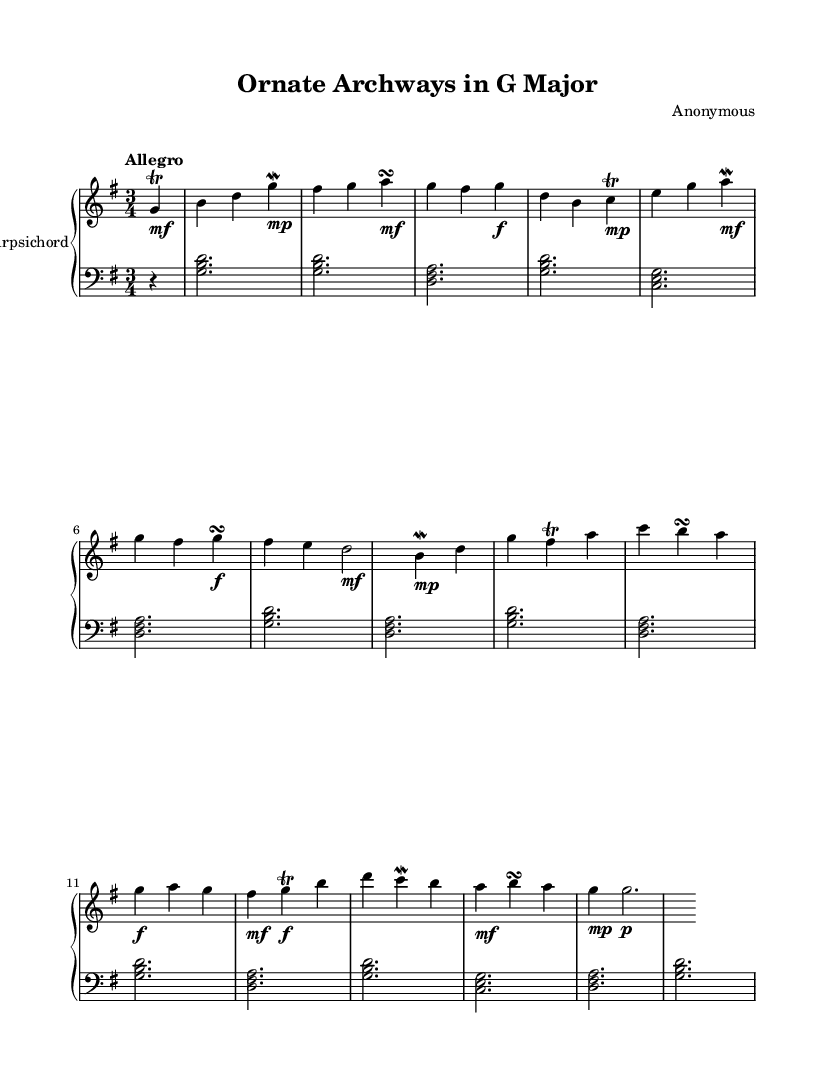What is the key signature of this music? The key signature is indicated at the beginning of the score, showing one sharp which is F#. This means the music is in G major.
Answer: G major What is the time signature of this piece? The time signature appears at the beginning as well, indicating three beats per measure, written as 3/4.
Answer: 3/4 What is the tempo marking of the composition? The tempo marking is located at the beginning of the score and states "Allegro," which indicates a fast tempo.
Answer: Allegro How many measures does the upper staff contain? By counting the number of vertical lines separating the notes in the upper staff, we see there are 14 measures.
Answer: 14 What type of ornamentation is used most frequently in this piece? Upon reviewing the upper staff, we see markings for trills and mordents applied to several notes, indicating the use of these ornaments.
Answer: Trills and mordents What is the dynamic marking for the final note in the upper staff? The final note has a dynamic marking labeled "p", which stands for "piano," indicating it should be played softly.
Answer: p What architectural feature is celebrated in the title of this composition? The title "Ornate Archways in G Major" specifically highlights the architectural detail of "archways" as the feature being celebrated.
Answer: Archways 